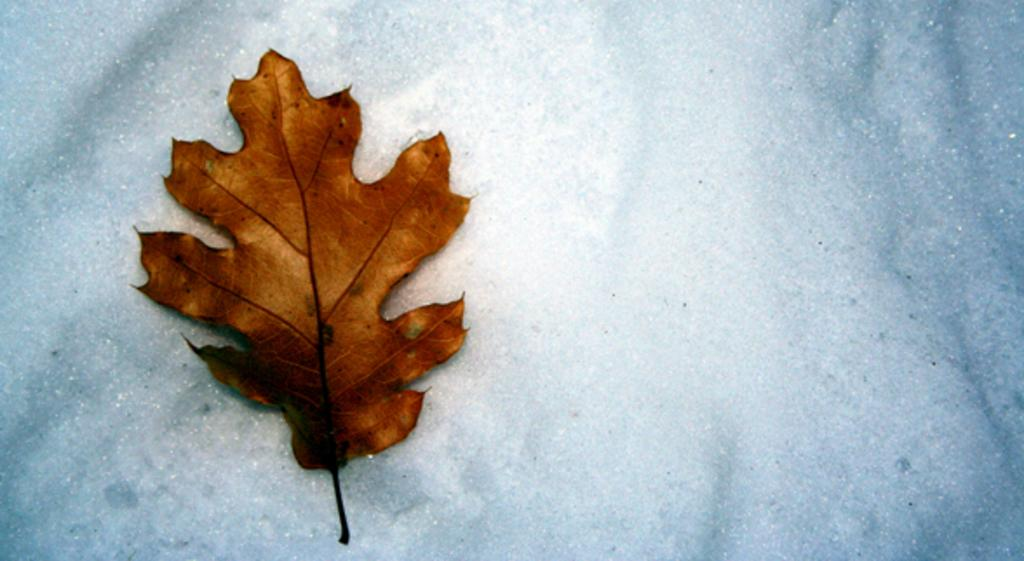What natural object can be seen in the image? There is a dried leaf in the image. What material is the object at the bottom of the image made of? There is a white marble at the bottom of the image. What type of tank is visible in the image? There is no tank present in the image. What is the afterthought in the image? The concept of an "afterthought" is not applicable to the image, as it contains only a dried leaf and a white marble. 